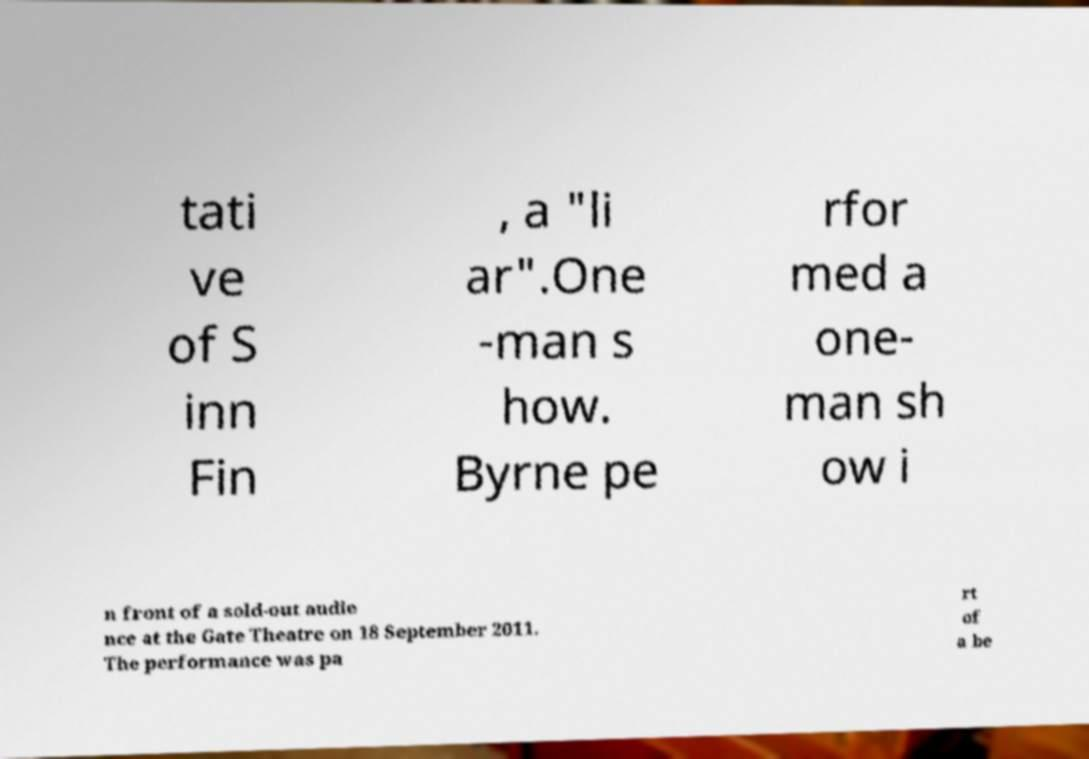Please identify and transcribe the text found in this image. tati ve of S inn Fin , a "li ar".One -man s how. Byrne pe rfor med a one- man sh ow i n front of a sold-out audie nce at the Gate Theatre on 18 September 2011. The performance was pa rt of a be 